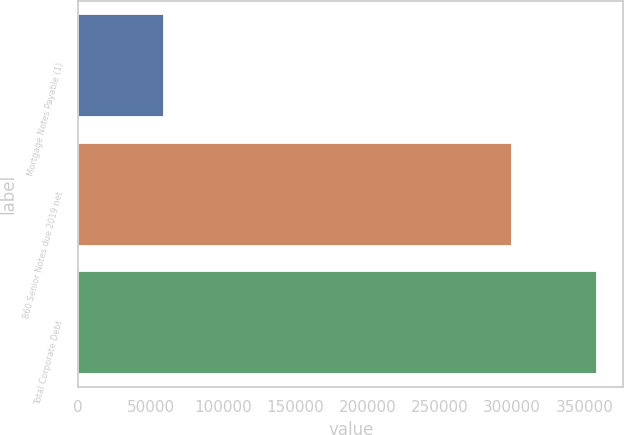Convert chart to OTSL. <chart><loc_0><loc_0><loc_500><loc_500><bar_chart><fcel>Mortgage Notes Payable (1)<fcel>860 Senior Notes due 2019 net<fcel>Total Corporate Debt<nl><fcel>59084<fcel>299950<fcel>359034<nl></chart> 